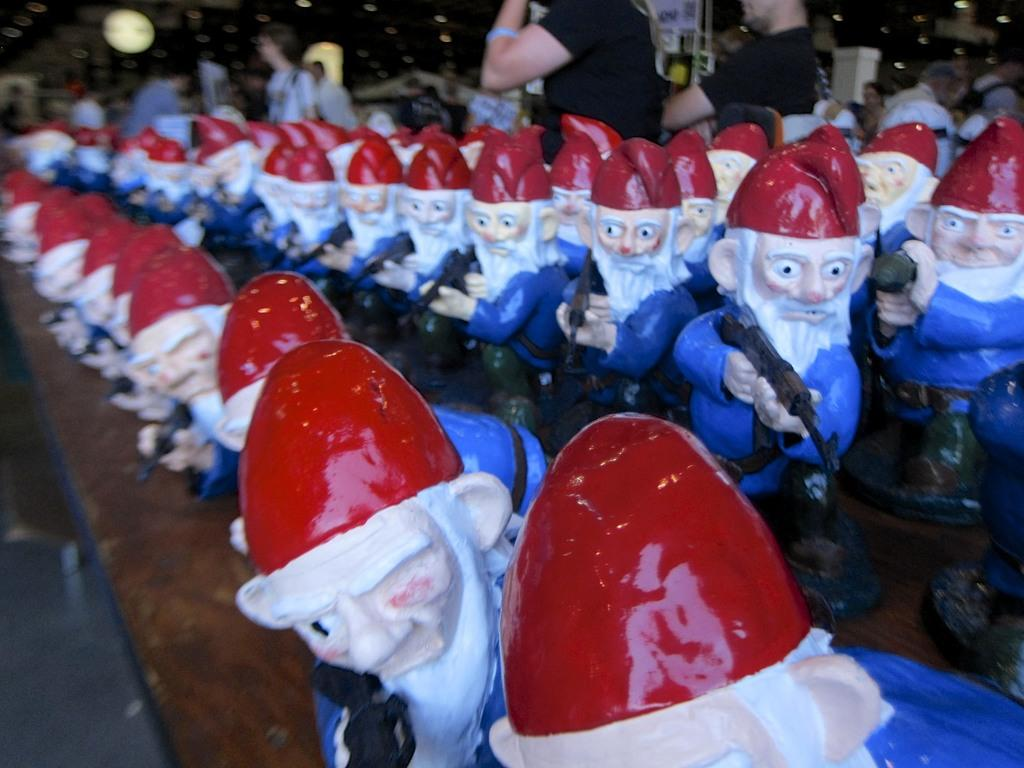What can be seen in the front of the image? There are puppets in the front of the image. What colors are the puppets? The puppets are blue, white, and red in color. What are the puppets holding? The puppets are holding guns. What is visible in the background of the image? There are persons in the background of the image. What can be seen in terms of lighting in the image? There are lights visible in the image. How many hands are visible on the puppets in the image? The image does not show the individual hands of the puppets, only the puppets themselves holding guns. 